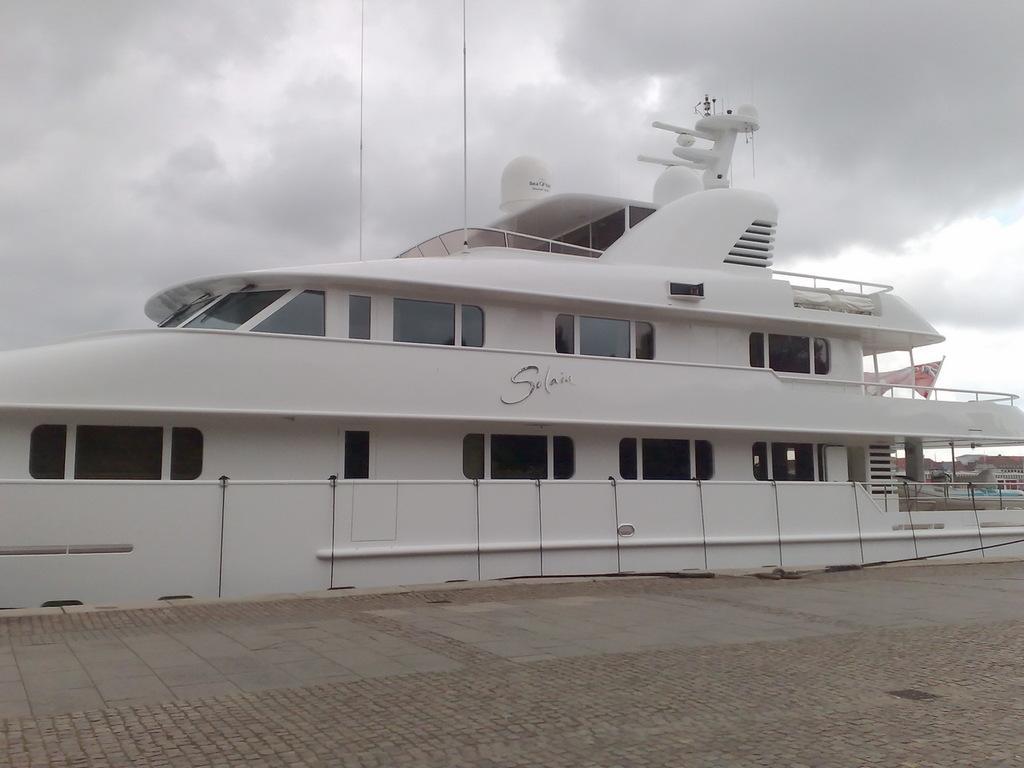In one or two sentences, can you explain what this image depicts? In this image, we can see the ship. At the bottom, there is a path. Background we can see the cloudy sky. On the right side of the image, we can see houses and flag. 